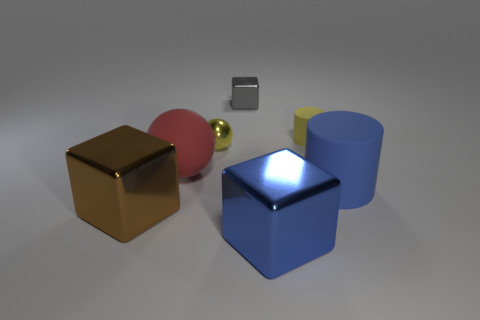The big thing that is the same color as the big rubber cylinder is what shape?
Make the answer very short. Cube. Is there a blue rubber cylinder behind the large rubber object that is to the left of the tiny yellow object on the left side of the large blue shiny object?
Offer a terse response. No. The brown metallic thing that is the same size as the red rubber ball is what shape?
Offer a very short reply. Cube. The other big thing that is the same shape as the big brown shiny thing is what color?
Your answer should be compact. Blue. What number of objects are either red matte cubes or tiny objects?
Keep it short and to the point. 3. Do the large blue object that is in front of the brown cube and the large rubber thing that is right of the yellow shiny ball have the same shape?
Keep it short and to the point. No. What is the shape of the big object that is right of the big blue cube?
Offer a very short reply. Cylinder. Are there an equal number of yellow matte cylinders to the left of the big sphere and yellow metal things in front of the blue metallic object?
Keep it short and to the point. Yes. What number of things are brown objects or rubber objects on the right side of the gray shiny cube?
Offer a terse response. 3. The object that is in front of the red matte object and left of the big blue metallic thing has what shape?
Your answer should be compact. Cube. 